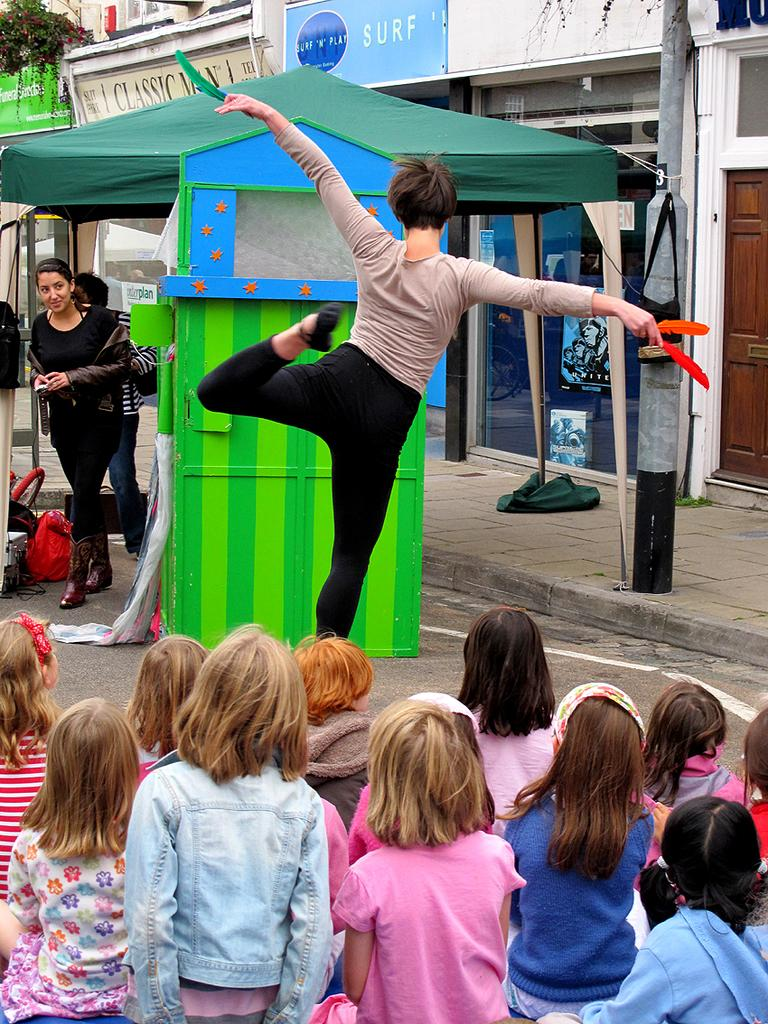How many people can be seen in the image? There are people in the image, but the exact number is not specified. What type of shelter is visible in the image? There is a tent in the image. What items are related to personal belongings or storage in the image? Clothes, bags, and objects are present in the image. What structure can be seen in the background of the image? Buildings are visible in the background of the image. What type of surface or material is present in the background of the image? Boards are present in the background of the image. What type of vegetation is visible in the background of the image? Plants and flowers are present in the background of the image. Is there any quicksand present in the image? No, there is no quicksand present in the image. What type of emotion is being expressed by the people in the image? The provided facts do not mention any emotions or expressions of the people in the image. How many attempts were made to set up the tent in the image? The provided facts do not mention any attempts or processes related to setting up the tent. 